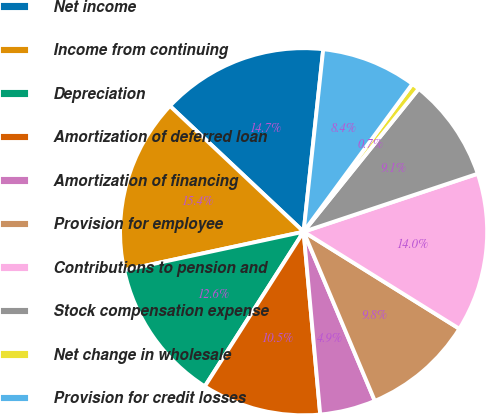<chart> <loc_0><loc_0><loc_500><loc_500><pie_chart><fcel>Net income<fcel>Income from continuing<fcel>Depreciation<fcel>Amortization of deferred loan<fcel>Amortization of financing<fcel>Provision for employee<fcel>Contributions to pension and<fcel>Stock compensation expense<fcel>Net change in wholesale<fcel>Provision for credit losses<nl><fcel>14.69%<fcel>15.38%<fcel>12.59%<fcel>10.49%<fcel>4.9%<fcel>9.79%<fcel>13.99%<fcel>9.09%<fcel>0.7%<fcel>8.39%<nl></chart> 